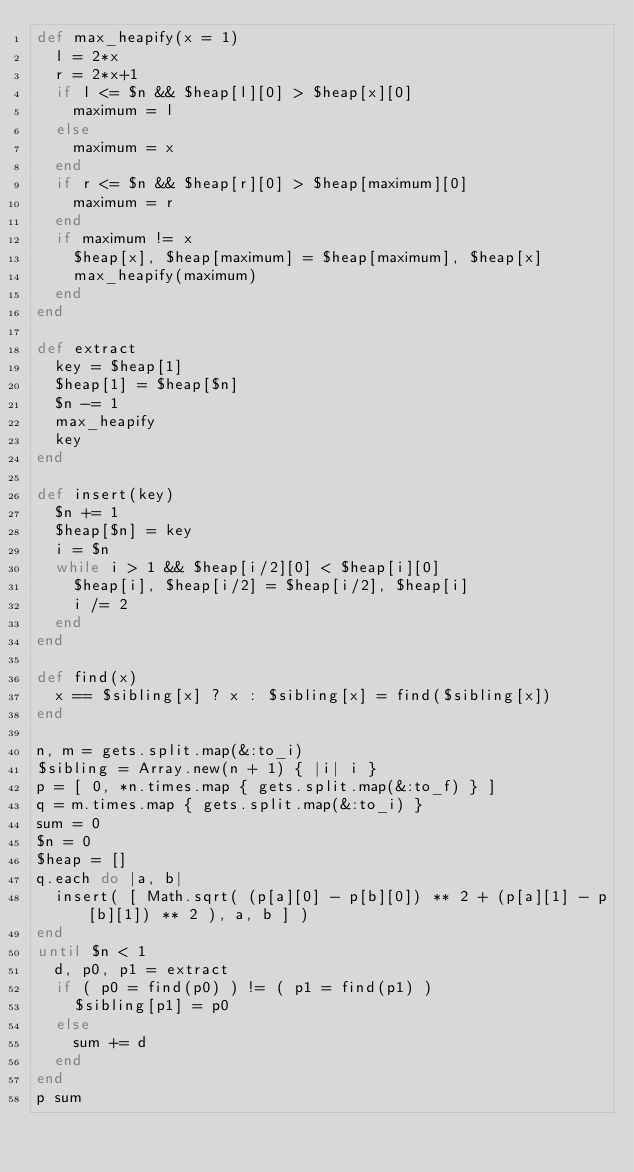Convert code to text. <code><loc_0><loc_0><loc_500><loc_500><_Ruby_>def max_heapify(x = 1)
  l = 2*x
  r = 2*x+1
  if l <= $n && $heap[l][0] > $heap[x][0]
    maximum = l
  else
    maximum = x
  end
  if r <= $n && $heap[r][0] > $heap[maximum][0]
    maximum = r
  end
  if maximum != x
    $heap[x], $heap[maximum] = $heap[maximum], $heap[x]
    max_heapify(maximum)
  end
end

def extract
  key = $heap[1]
  $heap[1] = $heap[$n]
  $n -= 1
  max_heapify
  key
end

def insert(key)
  $n += 1
  $heap[$n] = key
  i = $n
  while i > 1 && $heap[i/2][0] < $heap[i][0]
    $heap[i], $heap[i/2] = $heap[i/2], $heap[i]
    i /= 2
  end
end

def find(x)
  x == $sibling[x] ? x : $sibling[x] = find($sibling[x])
end

n, m = gets.split.map(&:to_i)
$sibling = Array.new(n + 1) { |i| i }
p = [ 0, *n.times.map { gets.split.map(&:to_f) } ]
q = m.times.map { gets.split.map(&:to_i) }
sum = 0
$n = 0
$heap = []
q.each do |a, b|
  insert( [ Math.sqrt( (p[a][0] - p[b][0]) ** 2 + (p[a][1] - p[b][1]) ** 2 ), a, b ] )
end
until $n < 1
  d, p0, p1 = extract
  if ( p0 = find(p0) ) != ( p1 = find(p1) )
    $sibling[p1] = p0
  else
    sum += d
  end
end
p sum</code> 